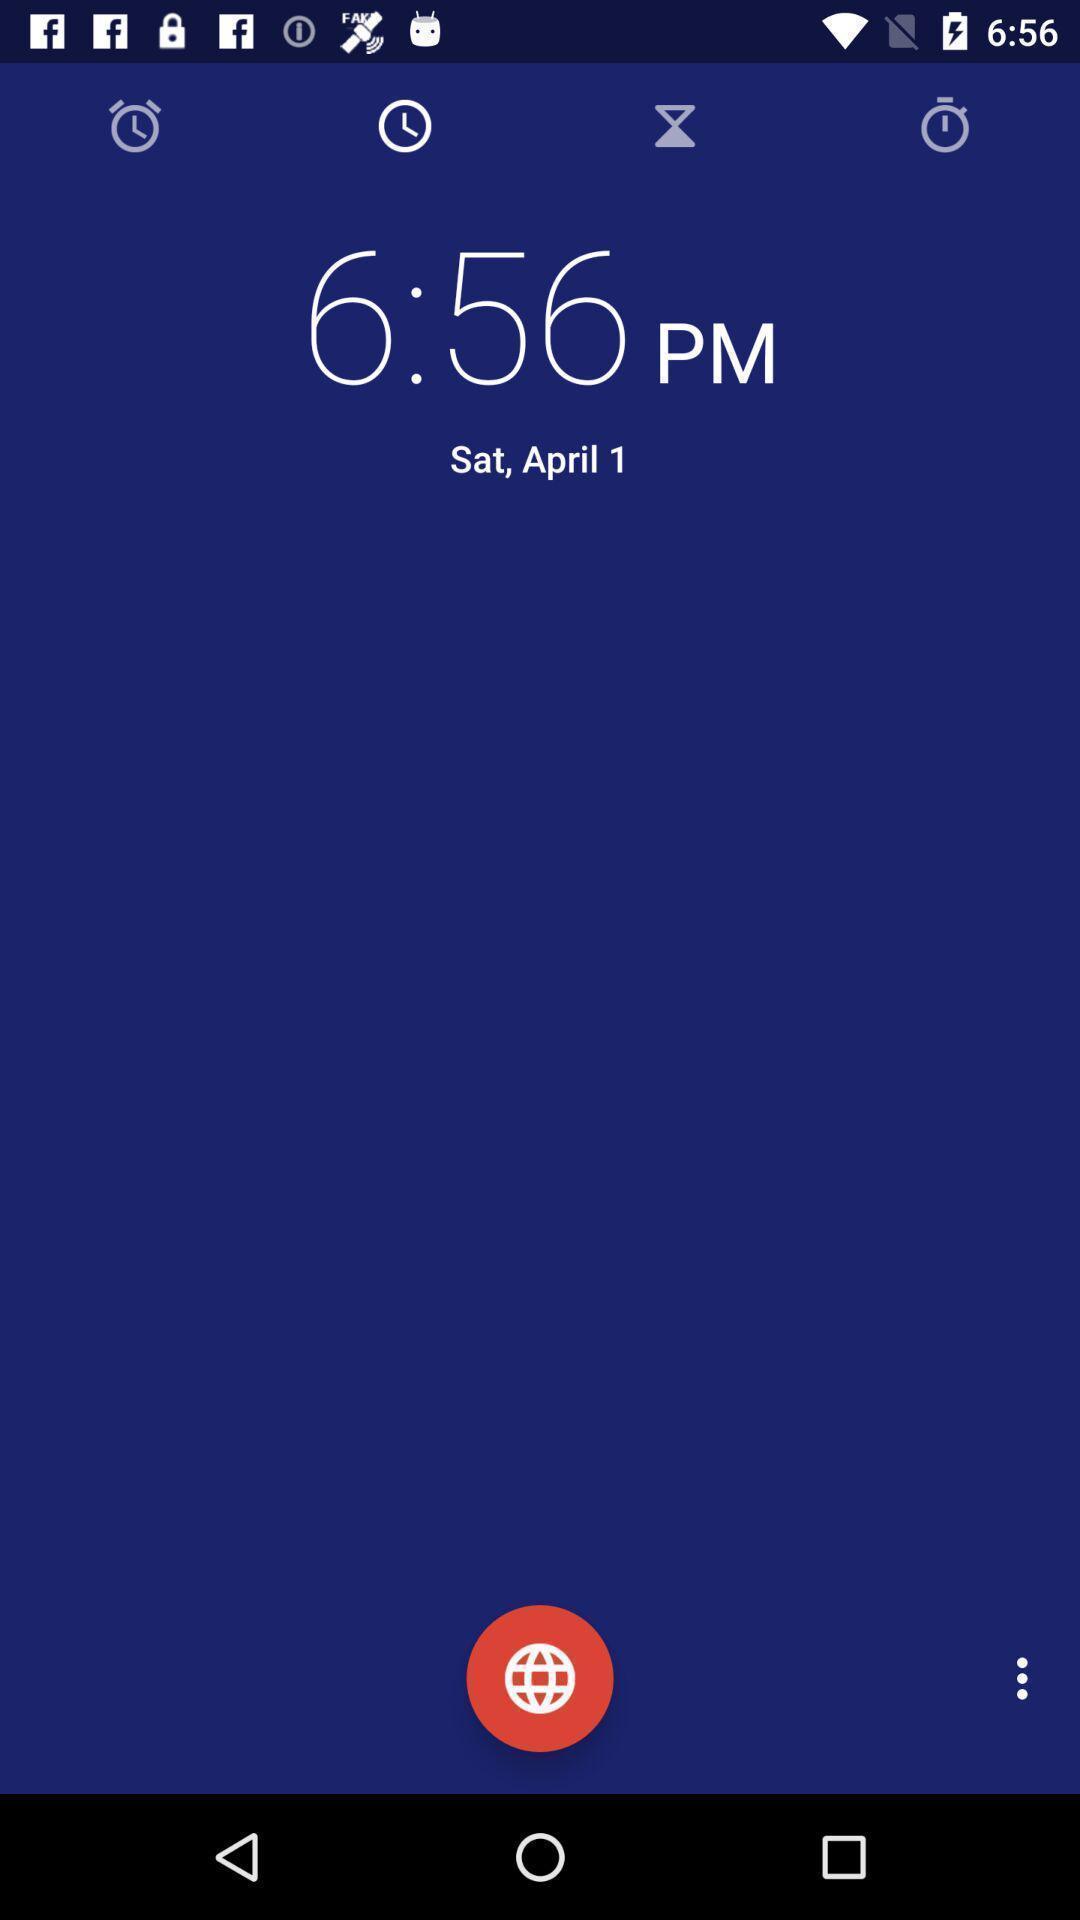What can you discern from this picture? Page showing categories in clock. 